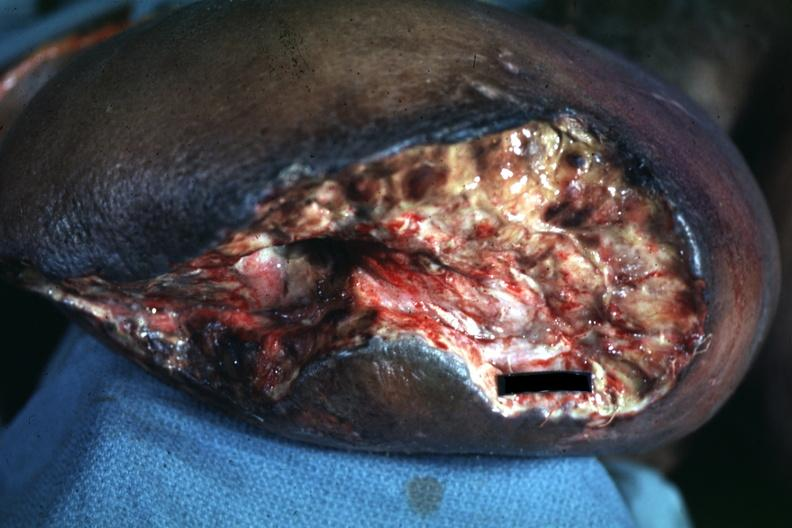what are present?
Answer the question using a single word or phrase. Extremities 